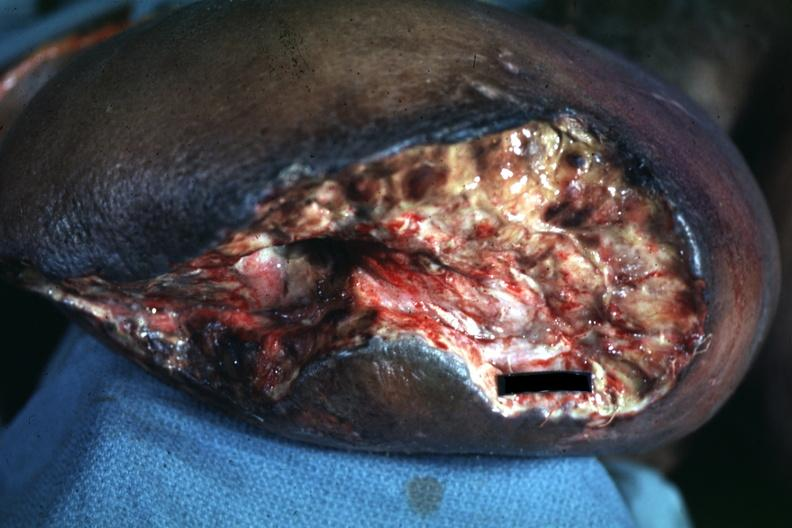what are present?
Answer the question using a single word or phrase. Extremities 